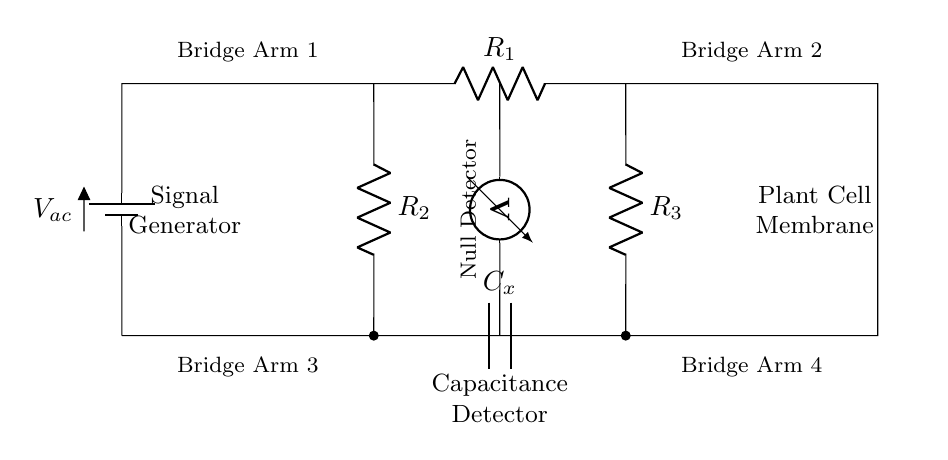What is the function of the capacitive component? The capacitive component represents the plant cell membrane capacitance, which is crucial for analyzing its electrical properties and behaviors under various conditions.
Answer: Capacitance What are the values for R1, R2, and R3? The circuit diagram does not specify numerical values for R1, R2, and R3; they are indicated as resistance components but are unspecified in this schematic.
Answer: Unspecified Which component serves as the null detector? The null detector is represented by the voltmeter in the circuit. It measures the potential difference across the bridge arms to indicate balance.
Answer: Voltmeter How many bridge arms are present in the circuit? The circuit consists of four bridge arms, each containing various components to balance the AC bridge.
Answer: Four What type of signal is applied to the circuit? An alternating current (AC) signal is applied to the circuit through the battery symbol indicated at the top.
Answer: AC Which bridge arm does Cx belong to? The capacitance component Cx is part of Bridge Arm 3, which connects R2 and R3 at the bottom of the circuit.
Answer: Bridge Arm 3 